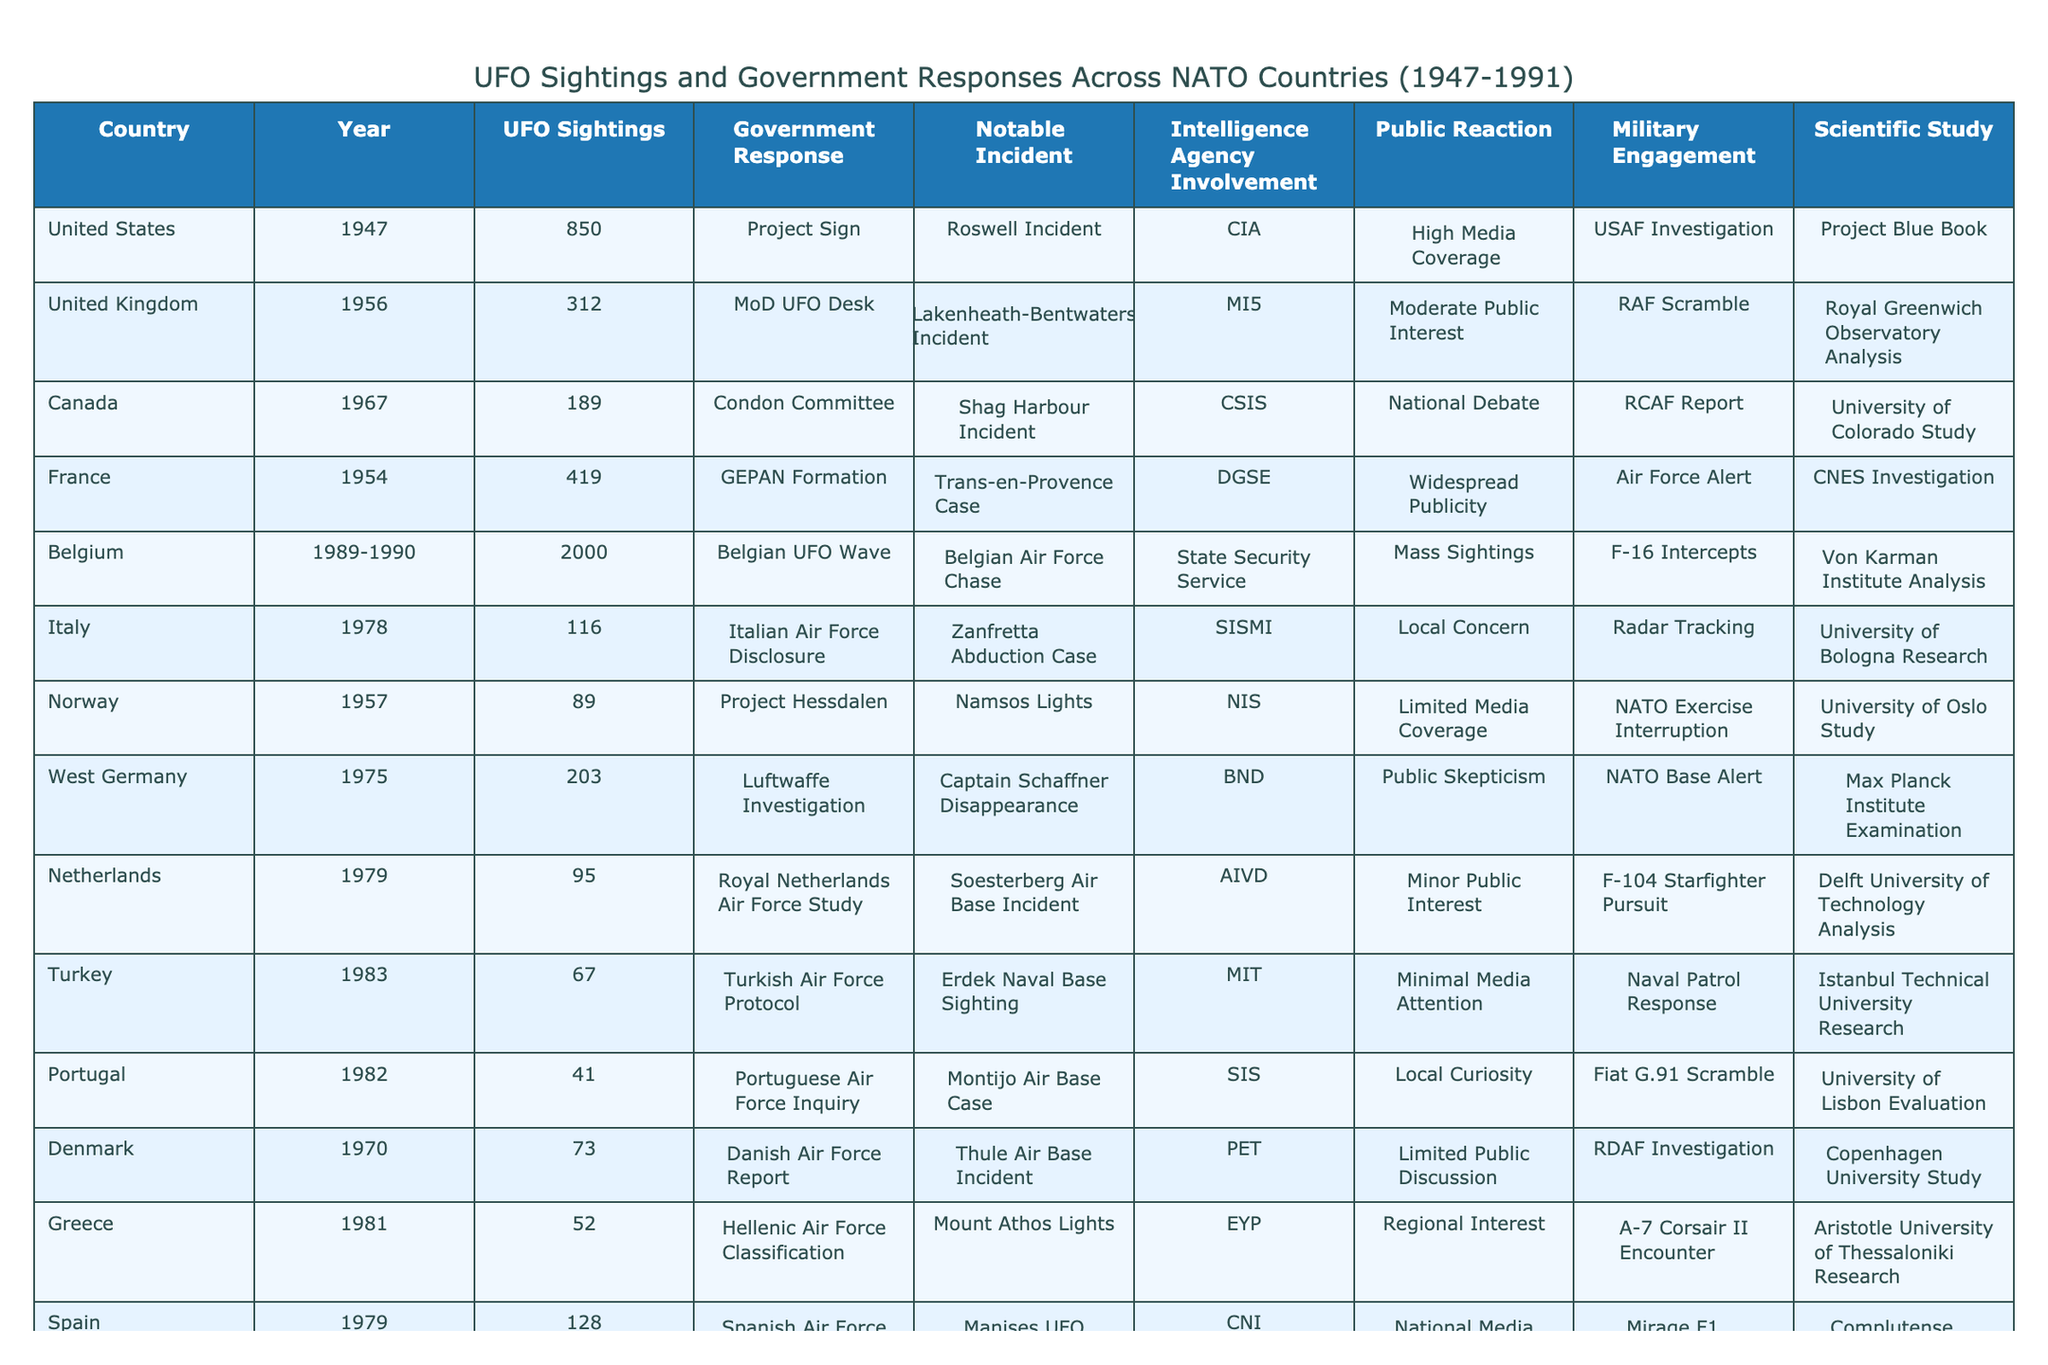How many UFO sightings were reported in Belgium during the Belgian UFO Wave? The table specifies that Belgium had 2000 UFO sightings during the years 1989-1990 under the category "Belgian UFO Wave."
Answer: 2000 Which country experienced the highest number of UFO sightings in the provided data? By comparing the UFO sightings from each country, the United States has the highest count at 850 sightings in 1947.
Answer: United States Did the Canadian government have an intelligence agency involved in the reported UFO sighting in 1967? Yes, the Canadian Security Intelligence Service (CSIS) was involved according to the table's data for 1967.
Answer: Yes What was the common public reaction to UFO sightings in the United Kingdom and France? Both the UK and France reported a degree of public interest, with the UK having moderate public interest and France experiencing widespread publicity.
Answer: Moderate public interest in the UK; widespread publicity in France Calculate the total number of UFO sightings reported across all countries in the table for the year 1982. The only two countries reported for 1982 are Turkey with 67 sightings and Portugal with 41 sightings. Summing these gives 67 + 41 = 108 sightings in total for 1982.
Answer: 108 Which notable incident in Italy involved an intelligence agency, and which agency was it? The notable incident in Italy is the "Zanfretta Abduction Case," which involved the Italian Military Intelligence Service (SISMI).
Answer: Zanfretta Abduction Case; SISMI What can we infer about the military engagement in Norway's UFO sighting incident compared to that in Turkey? Norway's incident in 1957 had limited media coverage and involved a NATO exercise interruption, while Turkey's 1983 sightings had minimal media attention and involved a naval patrol response. The military engagement in Norway appears to be related to NATO, indicating potential seriousness, while Turkey's seems less involved.
Answer: Norway had more significant military engagement compared to Turkey Did all countries listed have at least one intelligence agency involved in their reported UFO sightings? No, not all countries had intelligence agency involvement; Turkey's UFO sighting recorded minimal media attention and did not list any agency involvement.
Answer: No Determine if public reaction to sightings in the Netherlands was more or less compared to Iceland. The Netherlands had only minor public interest, while Iceland experienced localized concern, which suggests both had limited public reactions, but Iceland’s is slightly more pronounced.
Answer: More localized concern in Iceland than minor interest in the Netherlands 